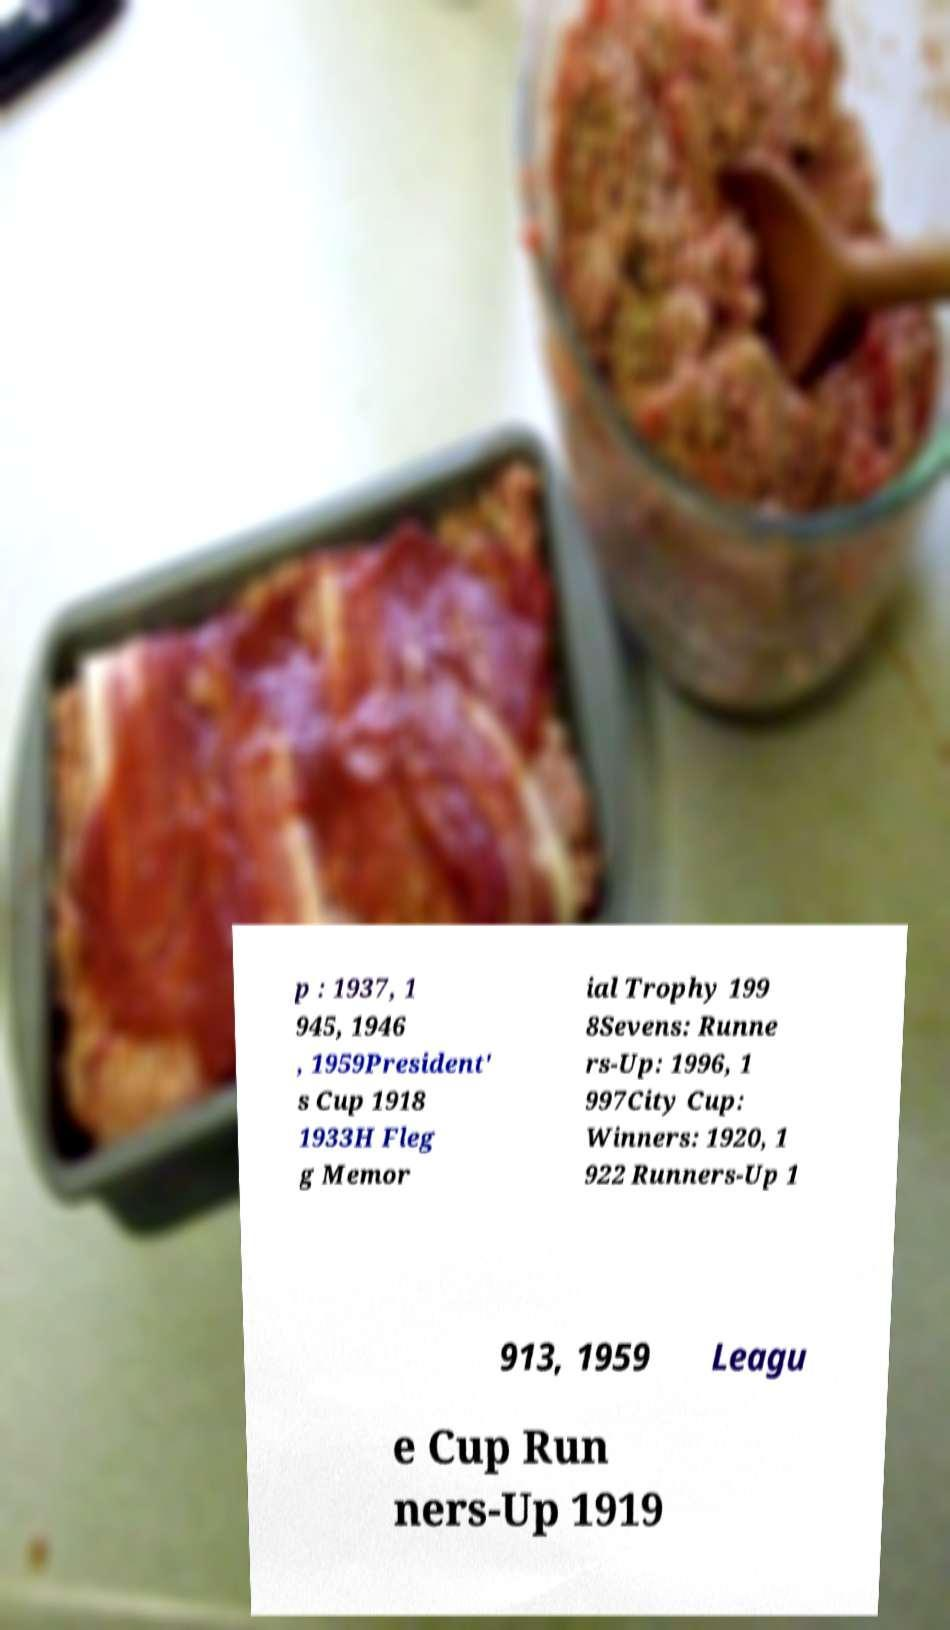For documentation purposes, I need the text within this image transcribed. Could you provide that? p : 1937, 1 945, 1946 , 1959President' s Cup 1918 1933H Fleg g Memor ial Trophy 199 8Sevens: Runne rs-Up: 1996, 1 997City Cup: Winners: 1920, 1 922 Runners-Up 1 913, 1959 Leagu e Cup Run ners-Up 1919 